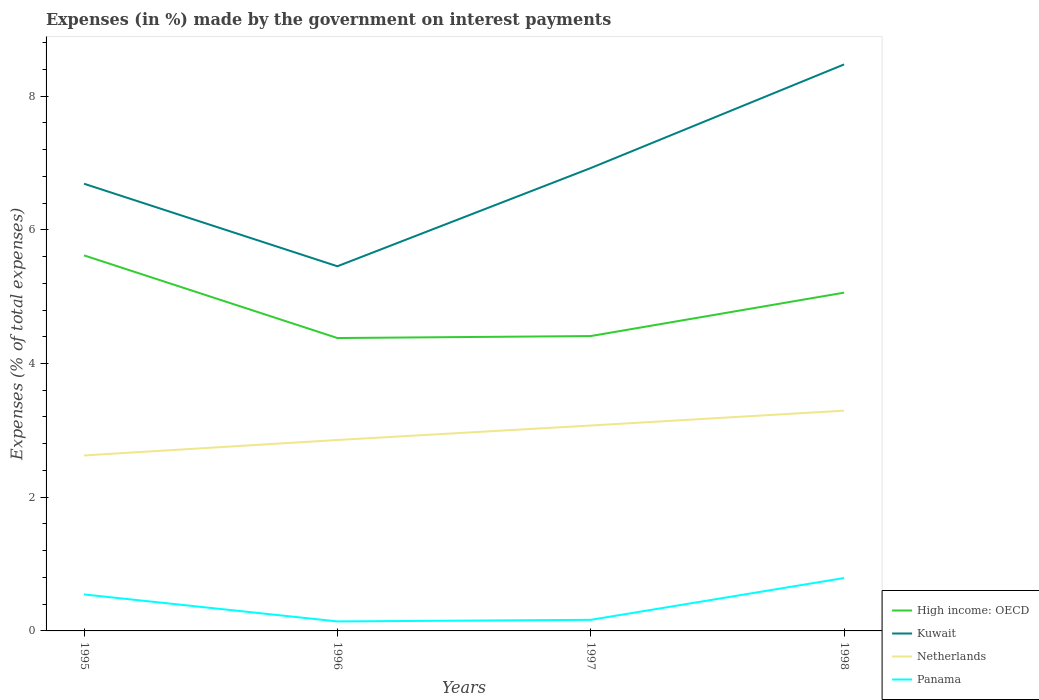How many different coloured lines are there?
Your answer should be very brief. 4. Is the number of lines equal to the number of legend labels?
Make the answer very short. Yes. Across all years, what is the maximum percentage of expenses made by the government on interest payments in High income: OECD?
Ensure brevity in your answer.  4.38. In which year was the percentage of expenses made by the government on interest payments in Netherlands maximum?
Give a very brief answer. 1995. What is the total percentage of expenses made by the government on interest payments in Netherlands in the graph?
Give a very brief answer. -0.44. What is the difference between the highest and the second highest percentage of expenses made by the government on interest payments in High income: OECD?
Your answer should be compact. 1.24. How many years are there in the graph?
Give a very brief answer. 4. What is the difference between two consecutive major ticks on the Y-axis?
Offer a very short reply. 2. Are the values on the major ticks of Y-axis written in scientific E-notation?
Keep it short and to the point. No. Does the graph contain any zero values?
Make the answer very short. No. Where does the legend appear in the graph?
Offer a terse response. Bottom right. How are the legend labels stacked?
Keep it short and to the point. Vertical. What is the title of the graph?
Your response must be concise. Expenses (in %) made by the government on interest payments. Does "Mauritius" appear as one of the legend labels in the graph?
Your response must be concise. No. What is the label or title of the Y-axis?
Your answer should be very brief. Expenses (% of total expenses). What is the Expenses (% of total expenses) of High income: OECD in 1995?
Ensure brevity in your answer.  5.62. What is the Expenses (% of total expenses) of Kuwait in 1995?
Your response must be concise. 6.69. What is the Expenses (% of total expenses) in Netherlands in 1995?
Provide a succinct answer. 2.62. What is the Expenses (% of total expenses) in Panama in 1995?
Give a very brief answer. 0.55. What is the Expenses (% of total expenses) in High income: OECD in 1996?
Your answer should be compact. 4.38. What is the Expenses (% of total expenses) of Kuwait in 1996?
Your answer should be very brief. 5.45. What is the Expenses (% of total expenses) in Netherlands in 1996?
Provide a succinct answer. 2.86. What is the Expenses (% of total expenses) of Panama in 1996?
Offer a very short reply. 0.14. What is the Expenses (% of total expenses) of High income: OECD in 1997?
Offer a very short reply. 4.41. What is the Expenses (% of total expenses) in Kuwait in 1997?
Provide a succinct answer. 6.92. What is the Expenses (% of total expenses) in Netherlands in 1997?
Provide a succinct answer. 3.07. What is the Expenses (% of total expenses) of Panama in 1997?
Make the answer very short. 0.17. What is the Expenses (% of total expenses) of High income: OECD in 1998?
Keep it short and to the point. 5.06. What is the Expenses (% of total expenses) of Kuwait in 1998?
Offer a very short reply. 8.47. What is the Expenses (% of total expenses) in Netherlands in 1998?
Provide a short and direct response. 3.29. What is the Expenses (% of total expenses) of Panama in 1998?
Provide a succinct answer. 0.79. Across all years, what is the maximum Expenses (% of total expenses) of High income: OECD?
Keep it short and to the point. 5.62. Across all years, what is the maximum Expenses (% of total expenses) of Kuwait?
Your answer should be compact. 8.47. Across all years, what is the maximum Expenses (% of total expenses) in Netherlands?
Provide a short and direct response. 3.29. Across all years, what is the maximum Expenses (% of total expenses) in Panama?
Offer a very short reply. 0.79. Across all years, what is the minimum Expenses (% of total expenses) in High income: OECD?
Your answer should be compact. 4.38. Across all years, what is the minimum Expenses (% of total expenses) in Kuwait?
Offer a terse response. 5.45. Across all years, what is the minimum Expenses (% of total expenses) of Netherlands?
Provide a short and direct response. 2.62. Across all years, what is the minimum Expenses (% of total expenses) of Panama?
Offer a terse response. 0.14. What is the total Expenses (% of total expenses) in High income: OECD in the graph?
Keep it short and to the point. 19.47. What is the total Expenses (% of total expenses) of Kuwait in the graph?
Keep it short and to the point. 27.54. What is the total Expenses (% of total expenses) of Netherlands in the graph?
Ensure brevity in your answer.  11.85. What is the total Expenses (% of total expenses) of Panama in the graph?
Your answer should be compact. 1.65. What is the difference between the Expenses (% of total expenses) in High income: OECD in 1995 and that in 1996?
Keep it short and to the point. 1.24. What is the difference between the Expenses (% of total expenses) of Kuwait in 1995 and that in 1996?
Ensure brevity in your answer.  1.23. What is the difference between the Expenses (% of total expenses) of Netherlands in 1995 and that in 1996?
Your answer should be compact. -0.23. What is the difference between the Expenses (% of total expenses) of Panama in 1995 and that in 1996?
Offer a terse response. 0.4. What is the difference between the Expenses (% of total expenses) in High income: OECD in 1995 and that in 1997?
Give a very brief answer. 1.21. What is the difference between the Expenses (% of total expenses) in Kuwait in 1995 and that in 1997?
Your answer should be very brief. -0.23. What is the difference between the Expenses (% of total expenses) in Netherlands in 1995 and that in 1997?
Provide a short and direct response. -0.45. What is the difference between the Expenses (% of total expenses) in Panama in 1995 and that in 1997?
Ensure brevity in your answer.  0.38. What is the difference between the Expenses (% of total expenses) in High income: OECD in 1995 and that in 1998?
Ensure brevity in your answer.  0.56. What is the difference between the Expenses (% of total expenses) of Kuwait in 1995 and that in 1998?
Provide a short and direct response. -1.78. What is the difference between the Expenses (% of total expenses) in Netherlands in 1995 and that in 1998?
Offer a very short reply. -0.67. What is the difference between the Expenses (% of total expenses) of Panama in 1995 and that in 1998?
Ensure brevity in your answer.  -0.25. What is the difference between the Expenses (% of total expenses) of High income: OECD in 1996 and that in 1997?
Provide a succinct answer. -0.03. What is the difference between the Expenses (% of total expenses) in Kuwait in 1996 and that in 1997?
Keep it short and to the point. -1.47. What is the difference between the Expenses (% of total expenses) in Netherlands in 1996 and that in 1997?
Provide a short and direct response. -0.22. What is the difference between the Expenses (% of total expenses) in Panama in 1996 and that in 1997?
Keep it short and to the point. -0.02. What is the difference between the Expenses (% of total expenses) in High income: OECD in 1996 and that in 1998?
Provide a succinct answer. -0.68. What is the difference between the Expenses (% of total expenses) of Kuwait in 1996 and that in 1998?
Ensure brevity in your answer.  -3.02. What is the difference between the Expenses (% of total expenses) of Netherlands in 1996 and that in 1998?
Offer a terse response. -0.44. What is the difference between the Expenses (% of total expenses) in Panama in 1996 and that in 1998?
Offer a terse response. -0.65. What is the difference between the Expenses (% of total expenses) of High income: OECD in 1997 and that in 1998?
Your answer should be compact. -0.65. What is the difference between the Expenses (% of total expenses) in Kuwait in 1997 and that in 1998?
Your answer should be compact. -1.55. What is the difference between the Expenses (% of total expenses) of Netherlands in 1997 and that in 1998?
Keep it short and to the point. -0.22. What is the difference between the Expenses (% of total expenses) in Panama in 1997 and that in 1998?
Your answer should be very brief. -0.63. What is the difference between the Expenses (% of total expenses) of High income: OECD in 1995 and the Expenses (% of total expenses) of Kuwait in 1996?
Your response must be concise. 0.16. What is the difference between the Expenses (% of total expenses) in High income: OECD in 1995 and the Expenses (% of total expenses) in Netherlands in 1996?
Your answer should be compact. 2.76. What is the difference between the Expenses (% of total expenses) of High income: OECD in 1995 and the Expenses (% of total expenses) of Panama in 1996?
Offer a terse response. 5.48. What is the difference between the Expenses (% of total expenses) of Kuwait in 1995 and the Expenses (% of total expenses) of Netherlands in 1996?
Make the answer very short. 3.83. What is the difference between the Expenses (% of total expenses) of Kuwait in 1995 and the Expenses (% of total expenses) of Panama in 1996?
Give a very brief answer. 6.55. What is the difference between the Expenses (% of total expenses) of Netherlands in 1995 and the Expenses (% of total expenses) of Panama in 1996?
Provide a succinct answer. 2.48. What is the difference between the Expenses (% of total expenses) in High income: OECD in 1995 and the Expenses (% of total expenses) in Kuwait in 1997?
Make the answer very short. -1.31. What is the difference between the Expenses (% of total expenses) of High income: OECD in 1995 and the Expenses (% of total expenses) of Netherlands in 1997?
Keep it short and to the point. 2.54. What is the difference between the Expenses (% of total expenses) in High income: OECD in 1995 and the Expenses (% of total expenses) in Panama in 1997?
Offer a terse response. 5.45. What is the difference between the Expenses (% of total expenses) in Kuwait in 1995 and the Expenses (% of total expenses) in Netherlands in 1997?
Offer a very short reply. 3.62. What is the difference between the Expenses (% of total expenses) in Kuwait in 1995 and the Expenses (% of total expenses) in Panama in 1997?
Keep it short and to the point. 6.52. What is the difference between the Expenses (% of total expenses) in Netherlands in 1995 and the Expenses (% of total expenses) in Panama in 1997?
Keep it short and to the point. 2.46. What is the difference between the Expenses (% of total expenses) in High income: OECD in 1995 and the Expenses (% of total expenses) in Kuwait in 1998?
Your answer should be very brief. -2.86. What is the difference between the Expenses (% of total expenses) in High income: OECD in 1995 and the Expenses (% of total expenses) in Netherlands in 1998?
Ensure brevity in your answer.  2.32. What is the difference between the Expenses (% of total expenses) of High income: OECD in 1995 and the Expenses (% of total expenses) of Panama in 1998?
Your answer should be very brief. 4.83. What is the difference between the Expenses (% of total expenses) in Kuwait in 1995 and the Expenses (% of total expenses) in Netherlands in 1998?
Give a very brief answer. 3.39. What is the difference between the Expenses (% of total expenses) of Kuwait in 1995 and the Expenses (% of total expenses) of Panama in 1998?
Keep it short and to the point. 5.9. What is the difference between the Expenses (% of total expenses) of Netherlands in 1995 and the Expenses (% of total expenses) of Panama in 1998?
Provide a short and direct response. 1.83. What is the difference between the Expenses (% of total expenses) in High income: OECD in 1996 and the Expenses (% of total expenses) in Kuwait in 1997?
Make the answer very short. -2.54. What is the difference between the Expenses (% of total expenses) of High income: OECD in 1996 and the Expenses (% of total expenses) of Netherlands in 1997?
Offer a very short reply. 1.31. What is the difference between the Expenses (% of total expenses) in High income: OECD in 1996 and the Expenses (% of total expenses) in Panama in 1997?
Make the answer very short. 4.22. What is the difference between the Expenses (% of total expenses) in Kuwait in 1996 and the Expenses (% of total expenses) in Netherlands in 1997?
Provide a succinct answer. 2.38. What is the difference between the Expenses (% of total expenses) of Kuwait in 1996 and the Expenses (% of total expenses) of Panama in 1997?
Ensure brevity in your answer.  5.29. What is the difference between the Expenses (% of total expenses) of Netherlands in 1996 and the Expenses (% of total expenses) of Panama in 1997?
Offer a very short reply. 2.69. What is the difference between the Expenses (% of total expenses) in High income: OECD in 1996 and the Expenses (% of total expenses) in Kuwait in 1998?
Provide a short and direct response. -4.09. What is the difference between the Expenses (% of total expenses) in High income: OECD in 1996 and the Expenses (% of total expenses) in Netherlands in 1998?
Provide a short and direct response. 1.09. What is the difference between the Expenses (% of total expenses) in High income: OECD in 1996 and the Expenses (% of total expenses) in Panama in 1998?
Give a very brief answer. 3.59. What is the difference between the Expenses (% of total expenses) of Kuwait in 1996 and the Expenses (% of total expenses) of Netherlands in 1998?
Make the answer very short. 2.16. What is the difference between the Expenses (% of total expenses) of Kuwait in 1996 and the Expenses (% of total expenses) of Panama in 1998?
Your answer should be compact. 4.66. What is the difference between the Expenses (% of total expenses) in Netherlands in 1996 and the Expenses (% of total expenses) in Panama in 1998?
Offer a very short reply. 2.06. What is the difference between the Expenses (% of total expenses) in High income: OECD in 1997 and the Expenses (% of total expenses) in Kuwait in 1998?
Offer a very short reply. -4.06. What is the difference between the Expenses (% of total expenses) of High income: OECD in 1997 and the Expenses (% of total expenses) of Netherlands in 1998?
Offer a terse response. 1.12. What is the difference between the Expenses (% of total expenses) in High income: OECD in 1997 and the Expenses (% of total expenses) in Panama in 1998?
Give a very brief answer. 3.62. What is the difference between the Expenses (% of total expenses) of Kuwait in 1997 and the Expenses (% of total expenses) of Netherlands in 1998?
Provide a succinct answer. 3.63. What is the difference between the Expenses (% of total expenses) in Kuwait in 1997 and the Expenses (% of total expenses) in Panama in 1998?
Make the answer very short. 6.13. What is the difference between the Expenses (% of total expenses) of Netherlands in 1997 and the Expenses (% of total expenses) of Panama in 1998?
Your answer should be very brief. 2.28. What is the average Expenses (% of total expenses) in High income: OECD per year?
Ensure brevity in your answer.  4.87. What is the average Expenses (% of total expenses) in Kuwait per year?
Provide a short and direct response. 6.89. What is the average Expenses (% of total expenses) in Netherlands per year?
Offer a very short reply. 2.96. What is the average Expenses (% of total expenses) in Panama per year?
Offer a very short reply. 0.41. In the year 1995, what is the difference between the Expenses (% of total expenses) in High income: OECD and Expenses (% of total expenses) in Kuwait?
Your response must be concise. -1.07. In the year 1995, what is the difference between the Expenses (% of total expenses) of High income: OECD and Expenses (% of total expenses) of Netherlands?
Give a very brief answer. 2.99. In the year 1995, what is the difference between the Expenses (% of total expenses) in High income: OECD and Expenses (% of total expenses) in Panama?
Offer a terse response. 5.07. In the year 1995, what is the difference between the Expenses (% of total expenses) in Kuwait and Expenses (% of total expenses) in Netherlands?
Your response must be concise. 4.06. In the year 1995, what is the difference between the Expenses (% of total expenses) of Kuwait and Expenses (% of total expenses) of Panama?
Ensure brevity in your answer.  6.14. In the year 1995, what is the difference between the Expenses (% of total expenses) of Netherlands and Expenses (% of total expenses) of Panama?
Your response must be concise. 2.08. In the year 1996, what is the difference between the Expenses (% of total expenses) in High income: OECD and Expenses (% of total expenses) in Kuwait?
Your response must be concise. -1.07. In the year 1996, what is the difference between the Expenses (% of total expenses) in High income: OECD and Expenses (% of total expenses) in Netherlands?
Offer a very short reply. 1.53. In the year 1996, what is the difference between the Expenses (% of total expenses) of High income: OECD and Expenses (% of total expenses) of Panama?
Your response must be concise. 4.24. In the year 1996, what is the difference between the Expenses (% of total expenses) in Kuwait and Expenses (% of total expenses) in Netherlands?
Offer a terse response. 2.6. In the year 1996, what is the difference between the Expenses (% of total expenses) in Kuwait and Expenses (% of total expenses) in Panama?
Provide a short and direct response. 5.31. In the year 1996, what is the difference between the Expenses (% of total expenses) of Netherlands and Expenses (% of total expenses) of Panama?
Give a very brief answer. 2.71. In the year 1997, what is the difference between the Expenses (% of total expenses) of High income: OECD and Expenses (% of total expenses) of Kuwait?
Offer a very short reply. -2.51. In the year 1997, what is the difference between the Expenses (% of total expenses) in High income: OECD and Expenses (% of total expenses) in Netherlands?
Provide a short and direct response. 1.34. In the year 1997, what is the difference between the Expenses (% of total expenses) in High income: OECD and Expenses (% of total expenses) in Panama?
Provide a succinct answer. 4.24. In the year 1997, what is the difference between the Expenses (% of total expenses) in Kuwait and Expenses (% of total expenses) in Netherlands?
Your answer should be very brief. 3.85. In the year 1997, what is the difference between the Expenses (% of total expenses) of Kuwait and Expenses (% of total expenses) of Panama?
Keep it short and to the point. 6.76. In the year 1997, what is the difference between the Expenses (% of total expenses) in Netherlands and Expenses (% of total expenses) in Panama?
Ensure brevity in your answer.  2.91. In the year 1998, what is the difference between the Expenses (% of total expenses) of High income: OECD and Expenses (% of total expenses) of Kuwait?
Provide a short and direct response. -3.41. In the year 1998, what is the difference between the Expenses (% of total expenses) in High income: OECD and Expenses (% of total expenses) in Netherlands?
Your response must be concise. 1.76. In the year 1998, what is the difference between the Expenses (% of total expenses) in High income: OECD and Expenses (% of total expenses) in Panama?
Offer a terse response. 4.27. In the year 1998, what is the difference between the Expenses (% of total expenses) of Kuwait and Expenses (% of total expenses) of Netherlands?
Your response must be concise. 5.18. In the year 1998, what is the difference between the Expenses (% of total expenses) of Kuwait and Expenses (% of total expenses) of Panama?
Keep it short and to the point. 7.68. In the year 1998, what is the difference between the Expenses (% of total expenses) in Netherlands and Expenses (% of total expenses) in Panama?
Ensure brevity in your answer.  2.5. What is the ratio of the Expenses (% of total expenses) in High income: OECD in 1995 to that in 1996?
Your response must be concise. 1.28. What is the ratio of the Expenses (% of total expenses) in Kuwait in 1995 to that in 1996?
Provide a succinct answer. 1.23. What is the ratio of the Expenses (% of total expenses) in Netherlands in 1995 to that in 1996?
Provide a short and direct response. 0.92. What is the ratio of the Expenses (% of total expenses) of Panama in 1995 to that in 1996?
Your answer should be very brief. 3.84. What is the ratio of the Expenses (% of total expenses) in High income: OECD in 1995 to that in 1997?
Your answer should be very brief. 1.27. What is the ratio of the Expenses (% of total expenses) of Kuwait in 1995 to that in 1997?
Give a very brief answer. 0.97. What is the ratio of the Expenses (% of total expenses) in Netherlands in 1995 to that in 1997?
Your answer should be very brief. 0.85. What is the ratio of the Expenses (% of total expenses) in Panama in 1995 to that in 1997?
Your answer should be very brief. 3.29. What is the ratio of the Expenses (% of total expenses) of High income: OECD in 1995 to that in 1998?
Keep it short and to the point. 1.11. What is the ratio of the Expenses (% of total expenses) of Kuwait in 1995 to that in 1998?
Your response must be concise. 0.79. What is the ratio of the Expenses (% of total expenses) of Netherlands in 1995 to that in 1998?
Make the answer very short. 0.8. What is the ratio of the Expenses (% of total expenses) in Panama in 1995 to that in 1998?
Ensure brevity in your answer.  0.69. What is the ratio of the Expenses (% of total expenses) of High income: OECD in 1996 to that in 1997?
Your answer should be very brief. 0.99. What is the ratio of the Expenses (% of total expenses) of Kuwait in 1996 to that in 1997?
Your response must be concise. 0.79. What is the ratio of the Expenses (% of total expenses) in Netherlands in 1996 to that in 1997?
Keep it short and to the point. 0.93. What is the ratio of the Expenses (% of total expenses) of Panama in 1996 to that in 1997?
Offer a terse response. 0.86. What is the ratio of the Expenses (% of total expenses) in High income: OECD in 1996 to that in 1998?
Offer a terse response. 0.87. What is the ratio of the Expenses (% of total expenses) of Kuwait in 1996 to that in 1998?
Provide a short and direct response. 0.64. What is the ratio of the Expenses (% of total expenses) of Netherlands in 1996 to that in 1998?
Ensure brevity in your answer.  0.87. What is the ratio of the Expenses (% of total expenses) in Panama in 1996 to that in 1998?
Provide a succinct answer. 0.18. What is the ratio of the Expenses (% of total expenses) of High income: OECD in 1997 to that in 1998?
Offer a terse response. 0.87. What is the ratio of the Expenses (% of total expenses) in Kuwait in 1997 to that in 1998?
Keep it short and to the point. 0.82. What is the ratio of the Expenses (% of total expenses) in Netherlands in 1997 to that in 1998?
Ensure brevity in your answer.  0.93. What is the ratio of the Expenses (% of total expenses) in Panama in 1997 to that in 1998?
Your response must be concise. 0.21. What is the difference between the highest and the second highest Expenses (% of total expenses) of High income: OECD?
Offer a terse response. 0.56. What is the difference between the highest and the second highest Expenses (% of total expenses) in Kuwait?
Ensure brevity in your answer.  1.55. What is the difference between the highest and the second highest Expenses (% of total expenses) in Netherlands?
Your response must be concise. 0.22. What is the difference between the highest and the second highest Expenses (% of total expenses) in Panama?
Provide a succinct answer. 0.25. What is the difference between the highest and the lowest Expenses (% of total expenses) of High income: OECD?
Offer a very short reply. 1.24. What is the difference between the highest and the lowest Expenses (% of total expenses) in Kuwait?
Provide a succinct answer. 3.02. What is the difference between the highest and the lowest Expenses (% of total expenses) of Netherlands?
Your response must be concise. 0.67. What is the difference between the highest and the lowest Expenses (% of total expenses) in Panama?
Provide a succinct answer. 0.65. 